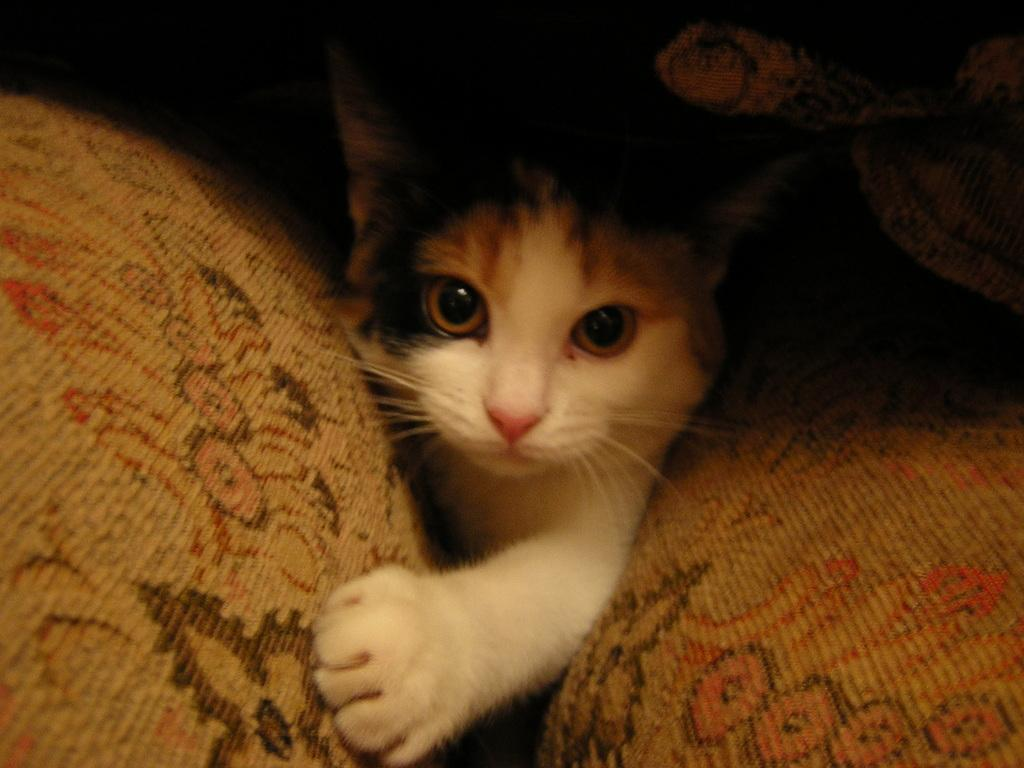What type of animal is in the image? There is a cat in the image. Can you describe the cat's coloring? The cat has black, brown, and white colors. Where is the cat positioned in relation to the brown-colored objects? The cat is between two brown-colored objects. What color is the background of the image? The background of the image is black. What action is the cat performing in the image? The image does not show the cat performing any specific action; it simply depicts the cat's appearance and position. How does the cat answer the question about its favorite food in the image? The image does not depict the cat answering any questions, as it is a still image and not a video or interactive medium. 